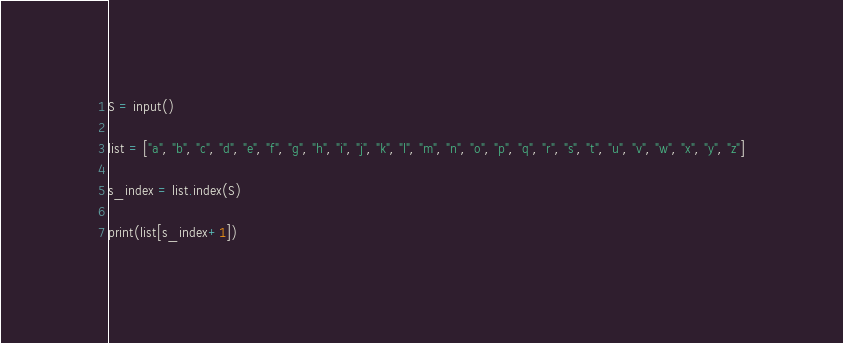<code> <loc_0><loc_0><loc_500><loc_500><_Python_>S = input()
 
list = ["a", "b", "c", "d", "e", "f", "g", "h", "i", "j", "k", "l", "m", "n", "o", "p", "q", "r", "s", "t", "u", "v", "w", "x", "y", "z"]
 
s_index = list.index(S)
 
print(list[s_index+1])</code> 